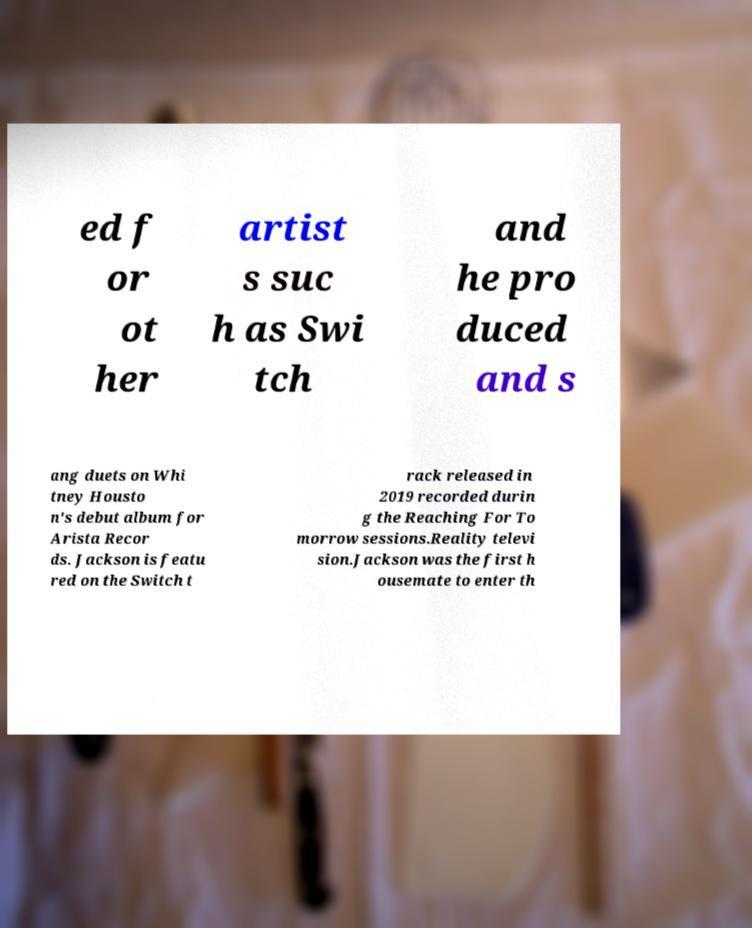I need the written content from this picture converted into text. Can you do that? ed f or ot her artist s suc h as Swi tch and he pro duced and s ang duets on Whi tney Housto n's debut album for Arista Recor ds. Jackson is featu red on the Switch t rack released in 2019 recorded durin g the Reaching For To morrow sessions.Reality televi sion.Jackson was the first h ousemate to enter th 